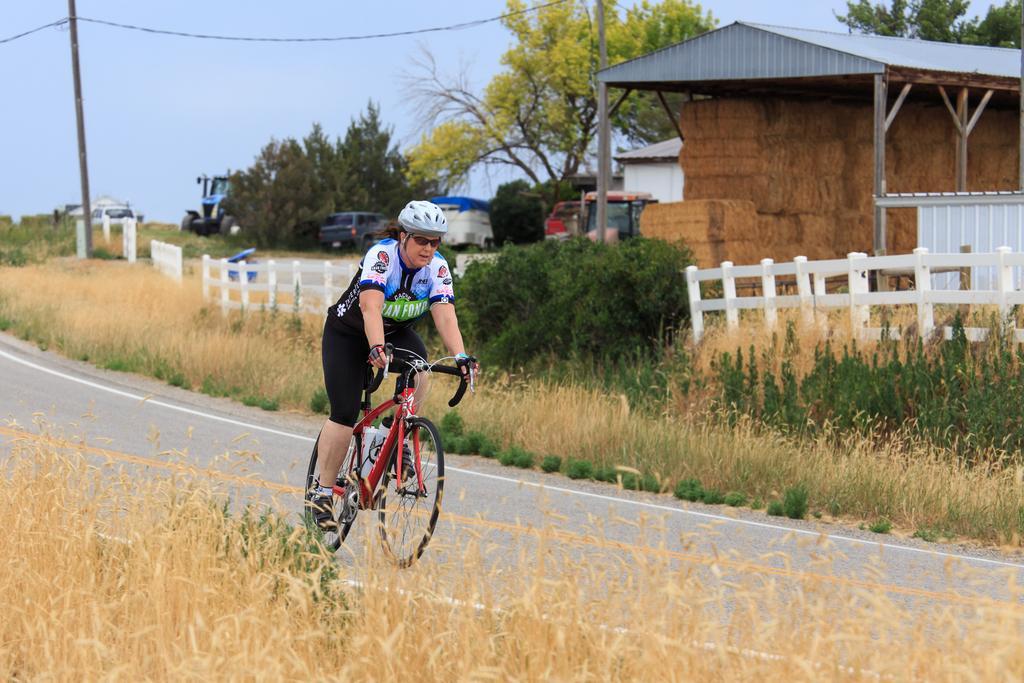How would you summarize this image in a sentence or two? In this image in the center there is one person who is sitting on a cycle and riding, and at the bottom of the image there are plants and walkway. And in the background there is a fencehouses, vehicles, trees, pole, wires and some plants and at the top there is sky. 